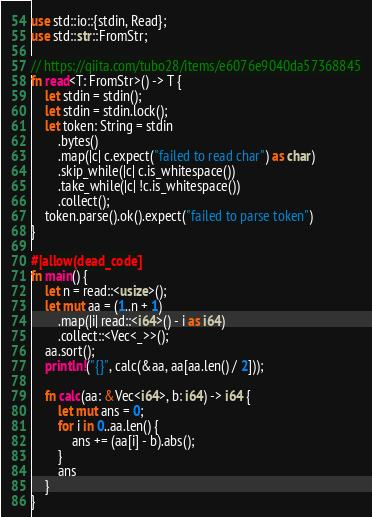<code> <loc_0><loc_0><loc_500><loc_500><_Rust_>use std::io::{stdin, Read};
use std::str::FromStr;

// https://qiita.com/tubo28/items/e6076e9040da57368845
fn read<T: FromStr>() -> T {
    let stdin = stdin();
    let stdin = stdin.lock();
    let token: String = stdin
        .bytes()
        .map(|c| c.expect("failed to read char") as char)
        .skip_while(|c| c.is_whitespace())
        .take_while(|c| !c.is_whitespace())
        .collect();
    token.parse().ok().expect("failed to parse token")
}

#[allow(dead_code)]
fn main() {
    let n = read::<usize>();
    let mut aa = (1..n + 1)
        .map(|i| read::<i64>() - i as i64)
        .collect::<Vec<_>>();
    aa.sort();
    println!("{}", calc(&aa, aa[aa.len() / 2]));

    fn calc(aa: &Vec<i64>, b: i64) -> i64 {
        let mut ans = 0;
        for i in 0..aa.len() {
            ans += (aa[i] - b).abs();
        }
        ans
    }
}
</code> 